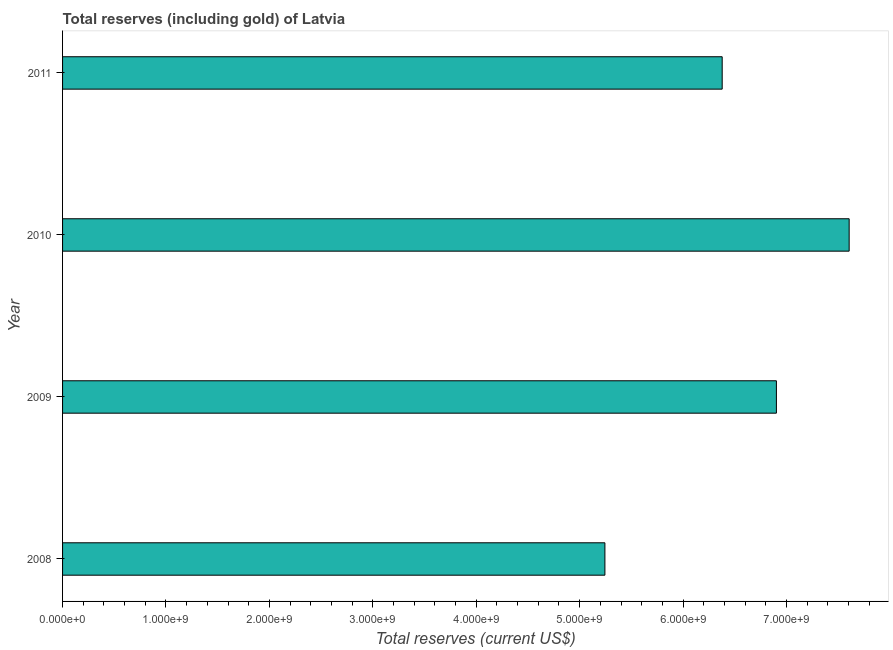Does the graph contain any zero values?
Your answer should be very brief. No. What is the title of the graph?
Your answer should be compact. Total reserves (including gold) of Latvia. What is the label or title of the X-axis?
Ensure brevity in your answer.  Total reserves (current US$). What is the total reserves (including gold) in 2009?
Offer a very short reply. 6.90e+09. Across all years, what is the maximum total reserves (including gold)?
Make the answer very short. 7.61e+09. Across all years, what is the minimum total reserves (including gold)?
Give a very brief answer. 5.24e+09. In which year was the total reserves (including gold) maximum?
Give a very brief answer. 2010. What is the sum of the total reserves (including gold)?
Make the answer very short. 2.61e+1. What is the difference between the total reserves (including gold) in 2010 and 2011?
Offer a very short reply. 1.23e+09. What is the average total reserves (including gold) per year?
Your response must be concise. 6.53e+09. What is the median total reserves (including gold)?
Your response must be concise. 6.64e+09. Do a majority of the years between 2009 and 2011 (inclusive) have total reserves (including gold) greater than 6000000000 US$?
Make the answer very short. Yes. What is the ratio of the total reserves (including gold) in 2008 to that in 2011?
Provide a succinct answer. 0.82. Is the difference between the total reserves (including gold) in 2008 and 2009 greater than the difference between any two years?
Offer a terse response. No. What is the difference between the highest and the second highest total reserves (including gold)?
Provide a short and direct response. 7.03e+08. What is the difference between the highest and the lowest total reserves (including gold)?
Your answer should be very brief. 2.36e+09. In how many years, is the total reserves (including gold) greater than the average total reserves (including gold) taken over all years?
Provide a succinct answer. 2. How many bars are there?
Provide a short and direct response. 4. Are all the bars in the graph horizontal?
Offer a terse response. Yes. How many years are there in the graph?
Make the answer very short. 4. What is the Total reserves (current US$) in 2008?
Keep it short and to the point. 5.24e+09. What is the Total reserves (current US$) in 2009?
Offer a very short reply. 6.90e+09. What is the Total reserves (current US$) of 2010?
Your answer should be very brief. 7.61e+09. What is the Total reserves (current US$) in 2011?
Provide a succinct answer. 6.38e+09. What is the difference between the Total reserves (current US$) in 2008 and 2009?
Offer a very short reply. -1.66e+09. What is the difference between the Total reserves (current US$) in 2008 and 2010?
Keep it short and to the point. -2.36e+09. What is the difference between the Total reserves (current US$) in 2008 and 2011?
Offer a very short reply. -1.13e+09. What is the difference between the Total reserves (current US$) in 2009 and 2010?
Your answer should be very brief. -7.03e+08. What is the difference between the Total reserves (current US$) in 2009 and 2011?
Make the answer very short. 5.24e+08. What is the difference between the Total reserves (current US$) in 2010 and 2011?
Offer a very short reply. 1.23e+09. What is the ratio of the Total reserves (current US$) in 2008 to that in 2009?
Give a very brief answer. 0.76. What is the ratio of the Total reserves (current US$) in 2008 to that in 2010?
Ensure brevity in your answer.  0.69. What is the ratio of the Total reserves (current US$) in 2008 to that in 2011?
Your response must be concise. 0.82. What is the ratio of the Total reserves (current US$) in 2009 to that in 2010?
Provide a short and direct response. 0.91. What is the ratio of the Total reserves (current US$) in 2009 to that in 2011?
Offer a very short reply. 1.08. What is the ratio of the Total reserves (current US$) in 2010 to that in 2011?
Your answer should be compact. 1.19. 